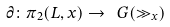Convert formula to latex. <formula><loc_0><loc_0><loc_500><loc_500>\partial \colon \pi _ { 2 } ( L , x ) \to \ G ( \gg _ { x } )</formula> 